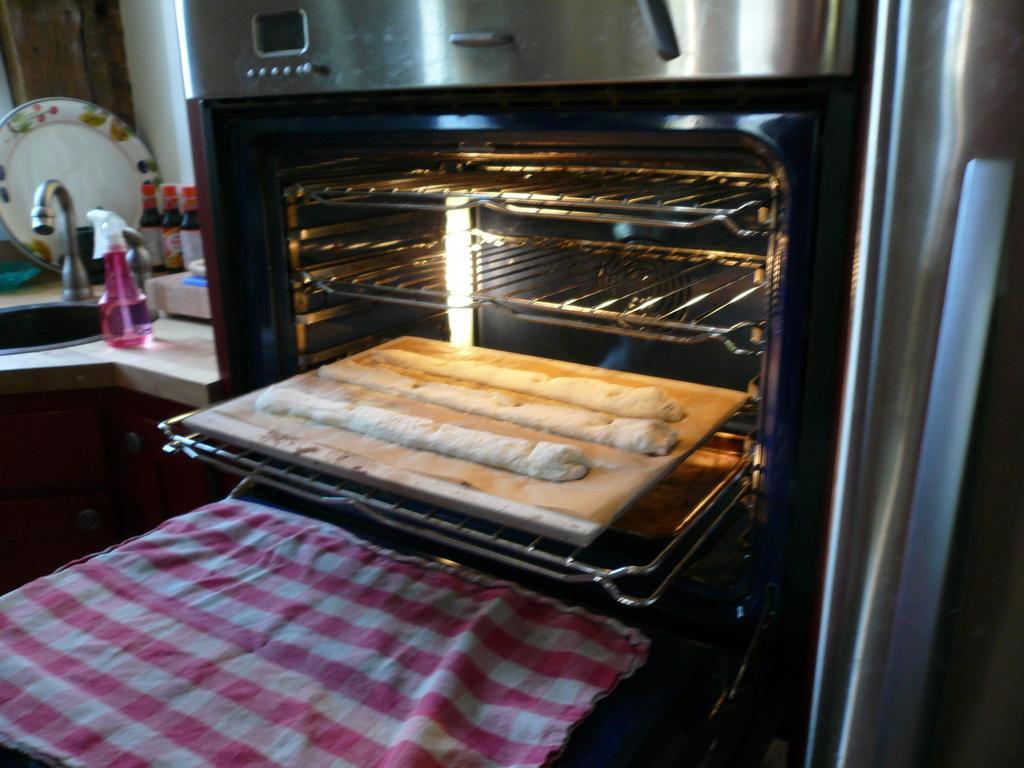Could you give a brief overview of what you see in this image? In this image I can see a cloth which is pink and white in color and a microwave oven which is black in color. I can see two grills and floor dough's in the microwave oven. I can see the counter top of the kitchen, a sink, a plate and few bottles. 